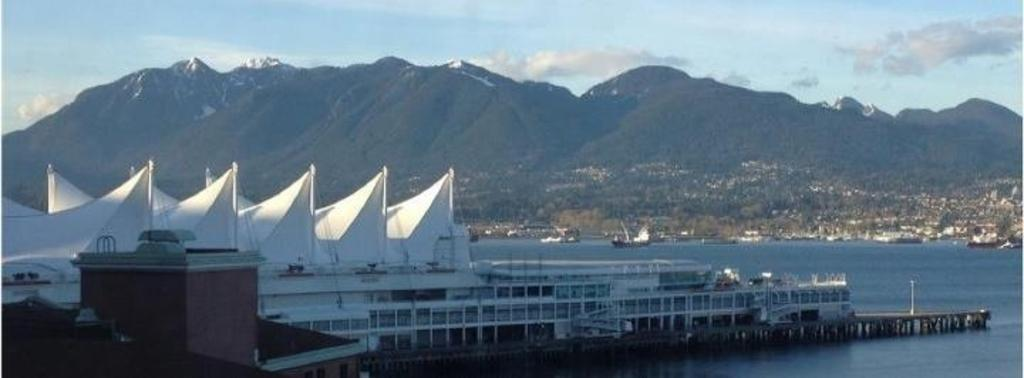What type of structures can be seen in the image? There are buildings in the image. What body of water is present in the image? There is a harbor and a sea in the image. What type of vehicles are in the image? There are ships in the image. What type of natural feature can be seen in the image? There are hills in the image. What part of the natural environment is visible in the image? The sky is visible in the image. What can be seen in the sky? There are clouds in the sky. What type of cheese is being used to poison the lock in the image? There is no cheese, poison, or lock present in the image. 